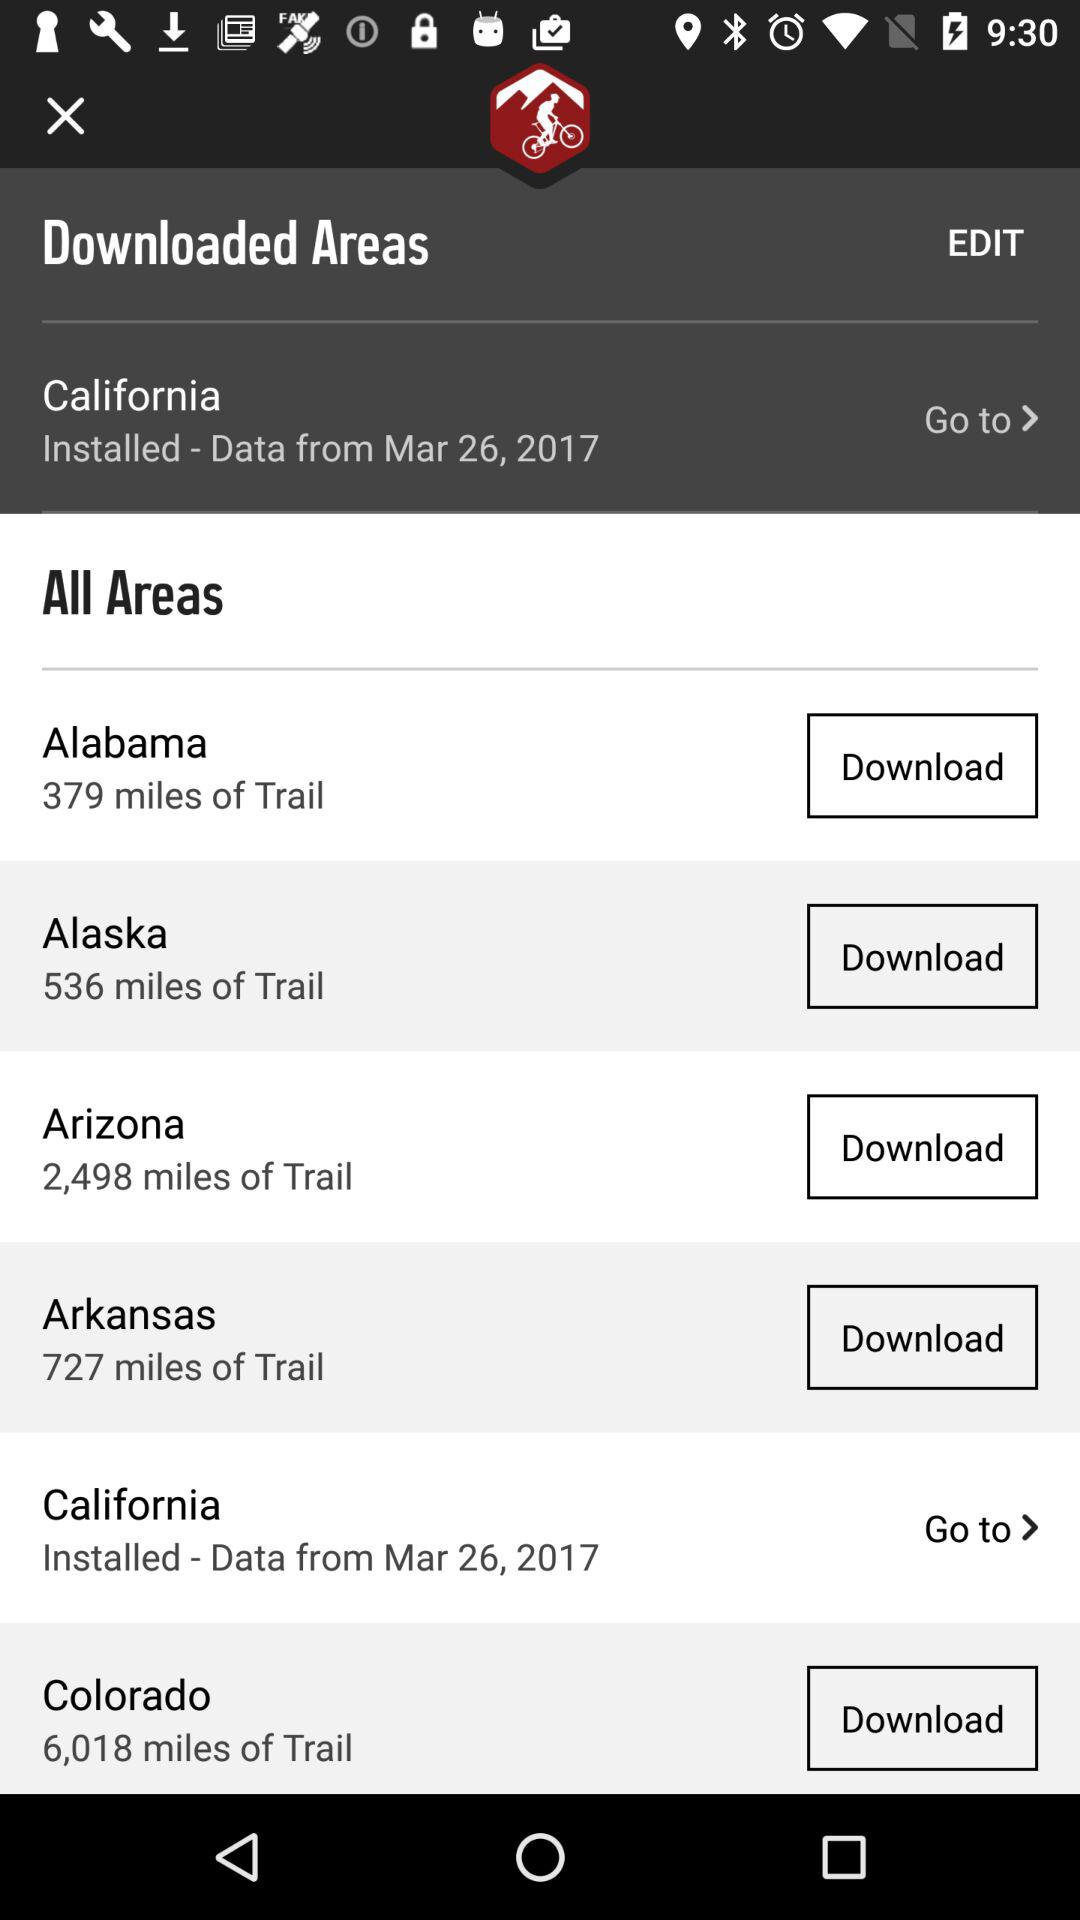What is the data installation date for California? The data installation date for California is March 26, 2017. 